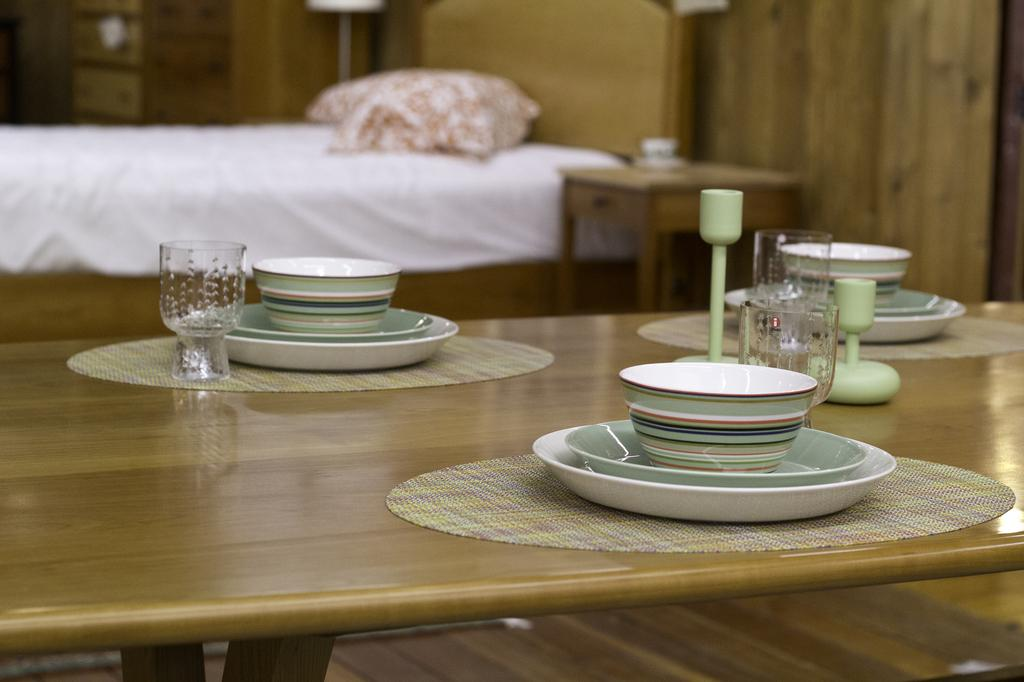What piece of furniture is present in the image? There is a bed in the image. What is placed on the bed? There is a pillow on the bed. What other piece of furniture is present in the image? There is a table in the image. What items can be seen on the table? There are glasses, a mat, bowls, and plates on the table. What type of whistle can be heard in the image? There is no whistle present in the image, and therefore no sound can be heard. 